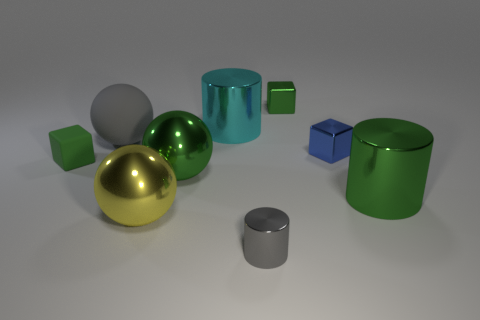Subtract all red cubes. Subtract all yellow spheres. How many cubes are left? 3 Add 1 small purple cylinders. How many objects exist? 10 Subtract all balls. How many objects are left? 6 Add 7 big gray objects. How many big gray objects are left? 8 Add 5 tiny metallic cylinders. How many tiny metallic cylinders exist? 6 Subtract 0 gray blocks. How many objects are left? 9 Subtract all big red rubber spheres. Subtract all big cyan metal cylinders. How many objects are left? 8 